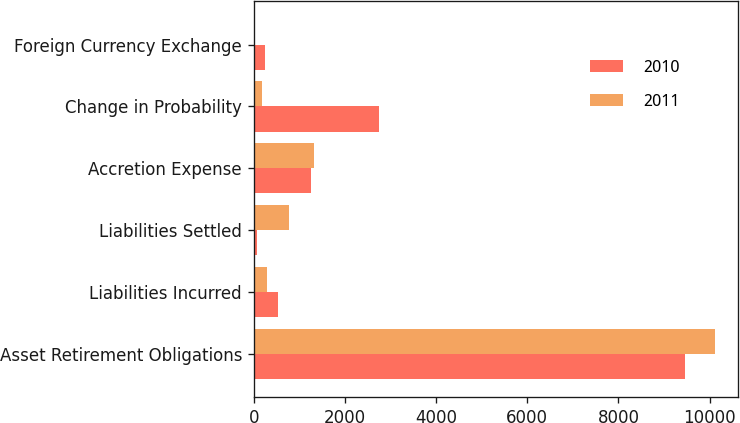<chart> <loc_0><loc_0><loc_500><loc_500><stacked_bar_chart><ecel><fcel>Asset Retirement Obligations<fcel>Liabilities Incurred<fcel>Liabilities Settled<fcel>Accretion Expense<fcel>Change in Probability<fcel>Foreign Currency Exchange<nl><fcel>2010<fcel>9465<fcel>531<fcel>70<fcel>1254<fcel>2745<fcel>239<nl><fcel>2011<fcel>10116<fcel>300<fcel>774<fcel>1327<fcel>176<fcel>26<nl></chart> 